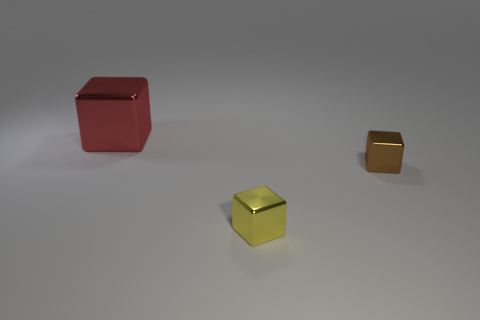Subtract all tiny metallic blocks. How many blocks are left? 1 Subtract 2 blocks. How many blocks are left? 1 Add 3 cubes. How many objects exist? 6 Subtract all cyan blocks. Subtract all brown cylinders. How many blocks are left? 3 Add 1 red metal objects. How many red metal objects are left? 2 Add 2 purple shiny cylinders. How many purple shiny cylinders exist? 2 Subtract 0 blue cubes. How many objects are left? 3 Subtract all red things. Subtract all red objects. How many objects are left? 1 